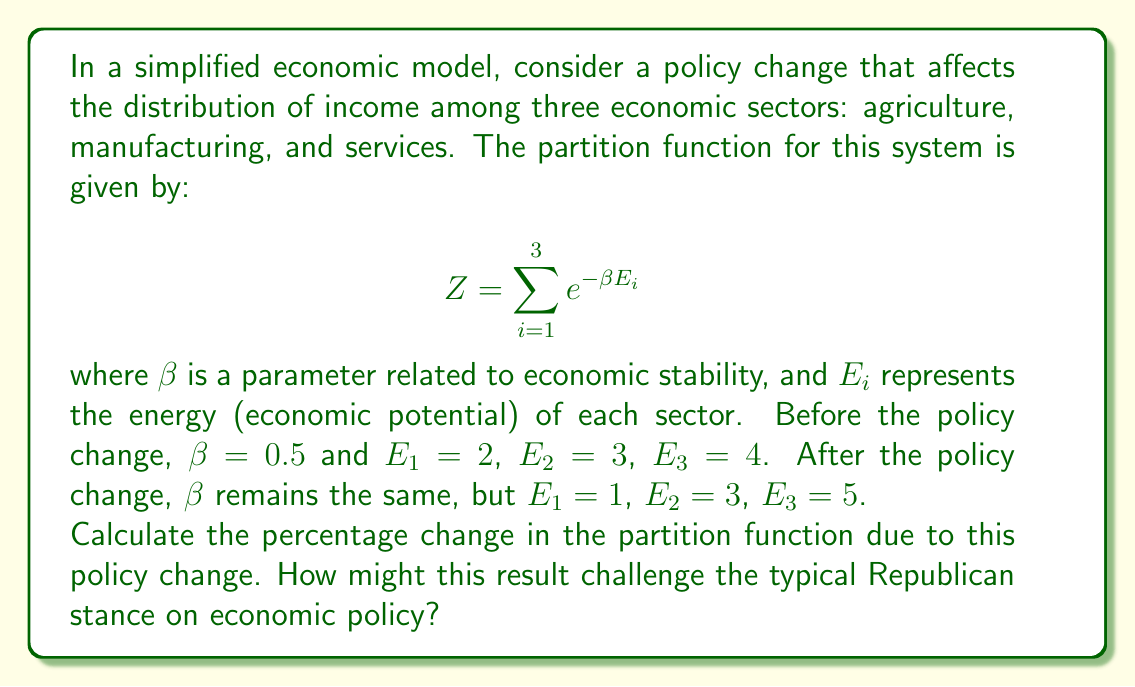Help me with this question. To solve this problem, we'll follow these steps:

1) Calculate the partition function before the policy change:
   $$Z_{before} = e^{-0.5 \cdot 2} + e^{-0.5 \cdot 3} + e^{-0.5 \cdot 4}$$
   $$Z_{before} = e^{-1} + e^{-1.5} + e^{-2}$$
   $$Z_{before} \approx 0.3679 + 0.2231 + 0.1353 = 0.7263$$

2) Calculate the partition function after the policy change:
   $$Z_{after} = e^{-0.5 \cdot 1} + e^{-0.5 \cdot 3} + e^{-0.5 \cdot 5}$$
   $$Z_{after} = e^{-0.5} + e^{-1.5} + e^{-2.5}$$
   $$Z_{after} \approx 0.6065 + 0.2231 + 0.0821 = 0.9117$$

3) Calculate the percentage change:
   $$\text{Percentage Change} = \frac{Z_{after} - Z_{before}}{Z_{before}} \cdot 100\%$$
   $$\text{Percentage Change} = \frac{0.9117 - 0.7263}{0.7263} \cdot 100\% \approx 25.53\%$$

This result shows a significant increase in the partition function, indicating a potential overall economic benefit from the policy change. This challenges the typical Republican stance on economic policy in several ways:

1) It suggests that redistributing economic potential (lowering it for agriculture and raising it for services) can lead to overall economic growth.
2) The model shows benefits from a policy that increases inequality between sectors, which goes against the traditional Republican focus on sector-neutral policies.
3) The significant positive impact might suggest that more government intervention in the economy (typically opposed by Republicans) can yield positive results.

These observations could prompt a Republican to reconsider their party's standard positions on economic policy and regulation.
Answer: 25.53% increase 